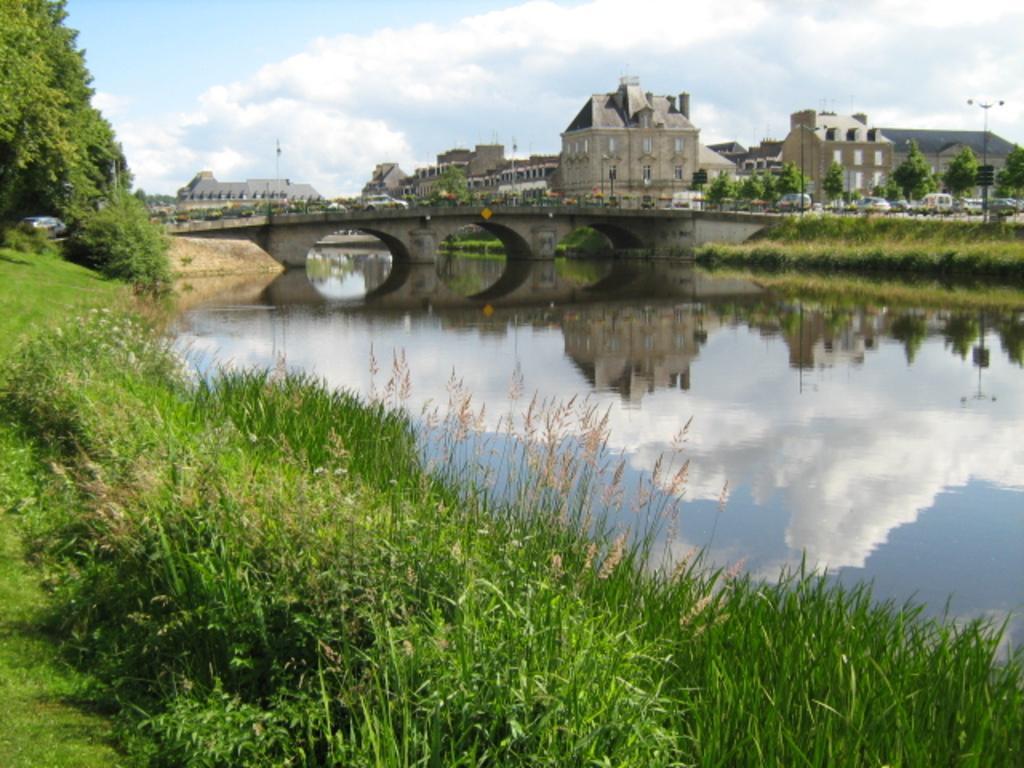Please provide a concise description of this image. In this picture there are few plants and trees in the left corner and there is water beside it and there is a bridge above it and there are few buildings,trees,vehicles and poles in the background. 